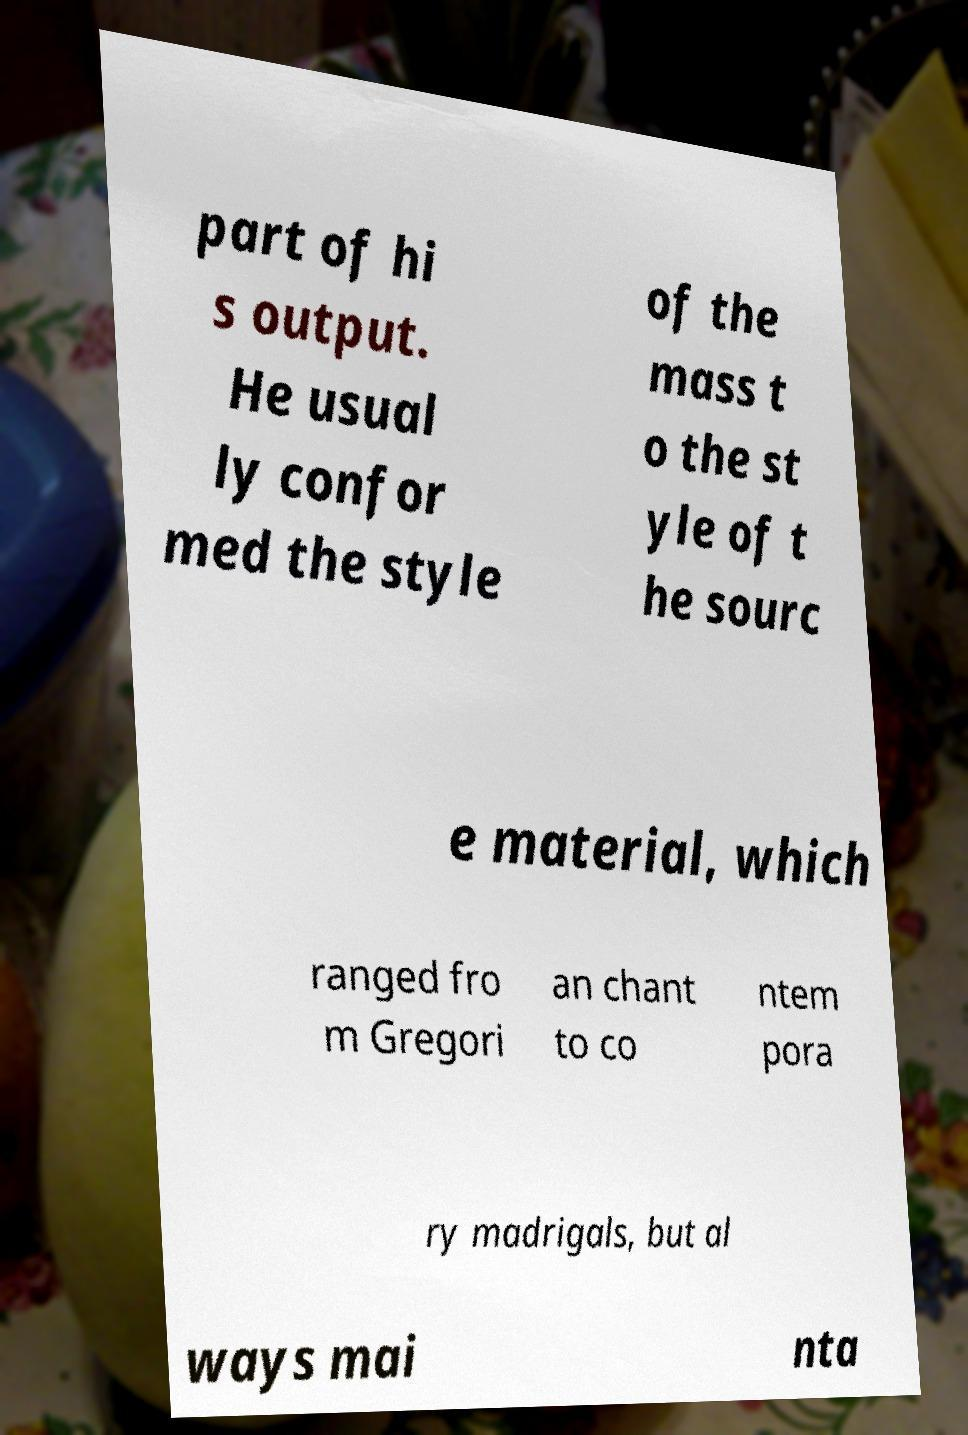Can you read and provide the text displayed in the image?This photo seems to have some interesting text. Can you extract and type it out for me? part of hi s output. He usual ly confor med the style of the mass t o the st yle of t he sourc e material, which ranged fro m Gregori an chant to co ntem pora ry madrigals, but al ways mai nta 